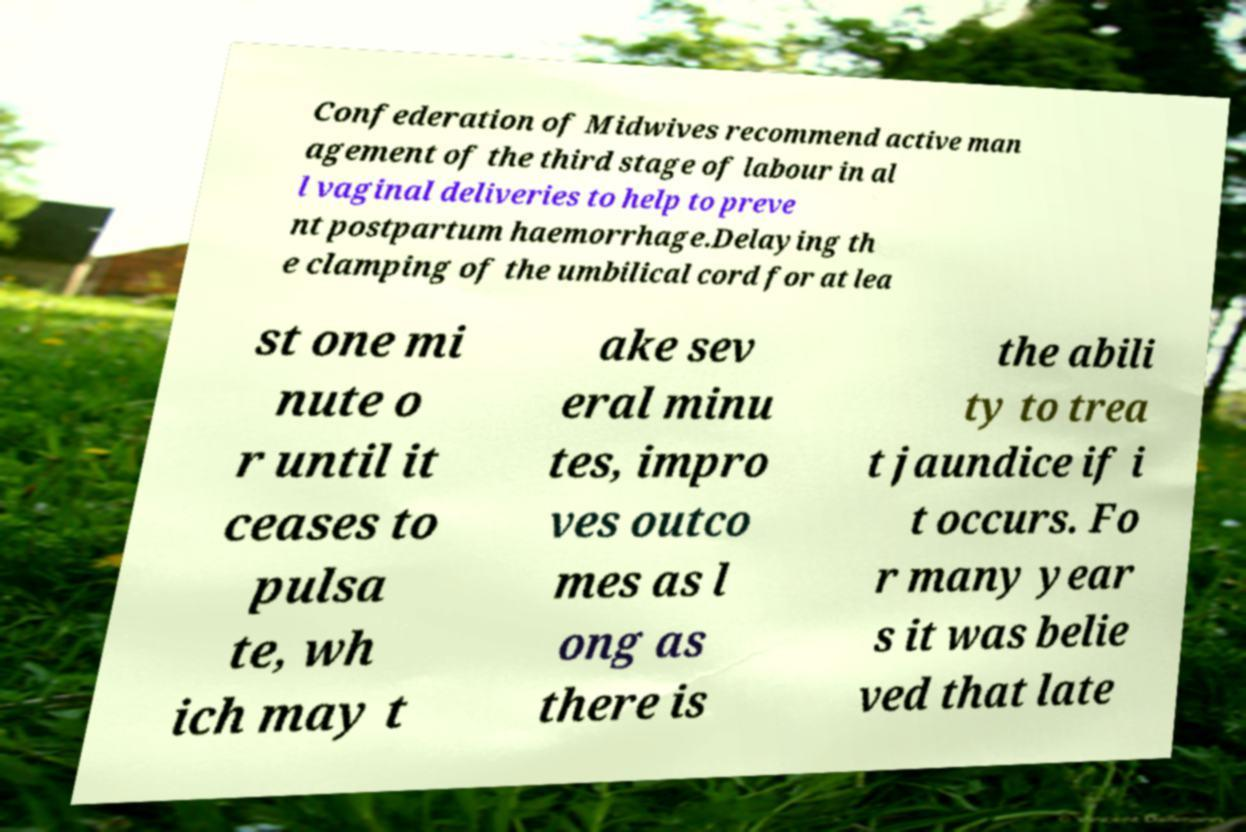Can you accurately transcribe the text from the provided image for me? Confederation of Midwives recommend active man agement of the third stage of labour in al l vaginal deliveries to help to preve nt postpartum haemorrhage.Delaying th e clamping of the umbilical cord for at lea st one mi nute o r until it ceases to pulsa te, wh ich may t ake sev eral minu tes, impro ves outco mes as l ong as there is the abili ty to trea t jaundice if i t occurs. Fo r many year s it was belie ved that late 